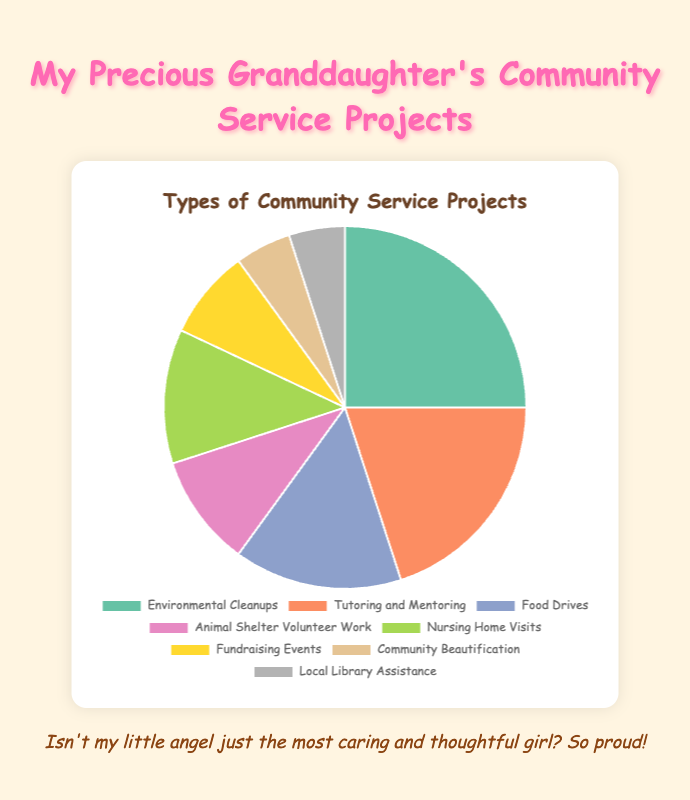What is the highest percentage project type? Looking at the pie chart, the largest portion corresponds to 'Environmental Cleanups' with a percentage of 25%.
Answer: Environmental Cleanups Which project type has the smallest percentage? By referring to the smallest sections of the pie chart, both 'Community Beautification' and 'Local Library Assistance' have the smallest percentage of 5%.
Answer: Community Beautification, Local Library Assistance How much greater is the percentage of 'Environmental Cleanups' compared to 'Fundraising Events'? 'Environmental Cleanups' is 25% and 'Fundraising Events' is 8%. The difference is 25% - 8% = 17%.
Answer: 17% What is the total percentage of all projects other than 'Environmental Cleanups' and 'Tutoring and Mentoring'? Sum of the percentages excluding 'Environmental Cleanups' (25%) and 'Tutoring and Mentoring' (20%) is 15% (Food Drives) + 10% (Animal Shelter Volunteer Work) + 12% (Nursing Home Visits) + 8% (Fundraising Events) + 5% (Community Beautification) + 5% (Local Library Assistance) = 55%.
Answer: 55% What are the two project types that have a combined percentage of 30%? Adding percentages, 'Tutoring and Mentoring' (20%) and 'Food Drives' (15%), you will see that they don't sum to 30%. Instead, 'Environmental Cleanups' (25%) combined with 'Fundraising Events' (8%) is 25% + 8% = 33%, separated 'Nursing Home Visits' (12%), added 'Animal Shelter Volunteer Work' (10%). So, the correct combination is 'Food Drives' (15%) + 'Nursing Home Visits' (12%) + 'Local Library Assistance' (5%) which together make 32%.
Answer: Tutoring and Mentoring, Local Library Assistance 